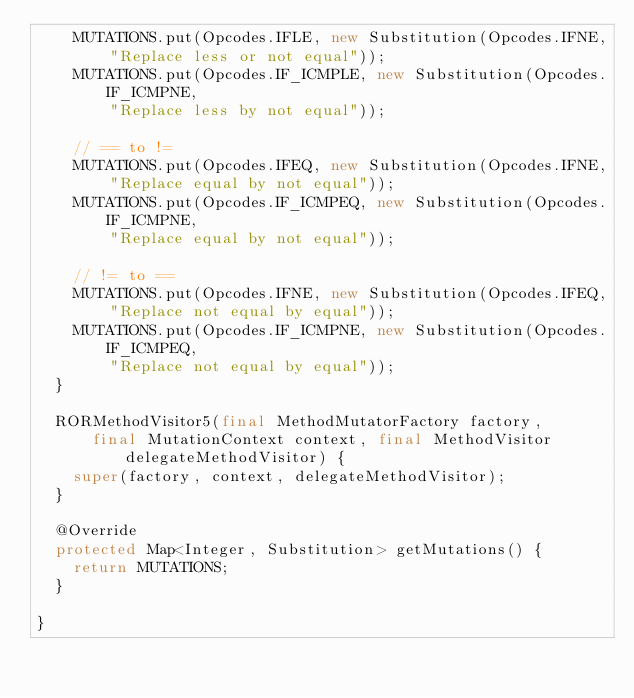Convert code to text. <code><loc_0><loc_0><loc_500><loc_500><_Java_>    MUTATIONS.put(Opcodes.IFLE, new Substitution(Opcodes.IFNE, 
        "Replace less or not equal"));
    MUTATIONS.put(Opcodes.IF_ICMPLE, new Substitution(Opcodes.IF_ICMPNE,
        "Replace less by not equal"));
            
    // == to !=
    MUTATIONS.put(Opcodes.IFEQ, new Substitution(Opcodes.IFNE,
        "Replace equal by not equal"));
    MUTATIONS.put(Opcodes.IF_ICMPEQ, new Substitution(Opcodes.IF_ICMPNE,
        "Replace equal by not equal"));
        
    // != to ==
    MUTATIONS.put(Opcodes.IFNE, new Substitution(Opcodes.IFEQ, 
        "Replace not equal by equal"));
    MUTATIONS.put(Opcodes.IF_ICMPNE, new Substitution(Opcodes.IF_ICMPEQ,
        "Replace not equal by equal"));
  }

  RORMethodVisitor5(final MethodMutatorFactory factory,
      final MutationContext context, final MethodVisitor delegateMethodVisitor) {
    super(factory, context, delegateMethodVisitor);
  }

  @Override
  protected Map<Integer, Substitution> getMutations() {
    return MUTATIONS;
  }

}</code> 